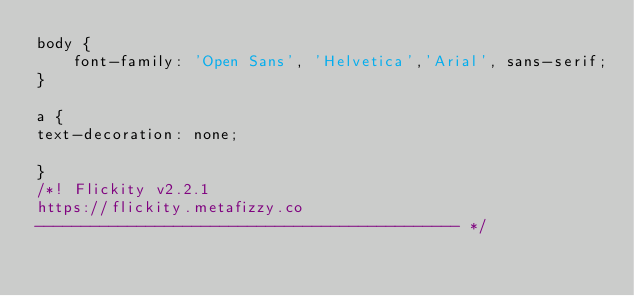Convert code to text. <code><loc_0><loc_0><loc_500><loc_500><_CSS_>body {
    font-family: 'Open Sans', 'Helvetica','Arial', sans-serif;
}

a {
text-decoration: none;

}
/*! Flickity v2.2.1
https://flickity.metafizzy.co
---------------------------------------------- */</code> 